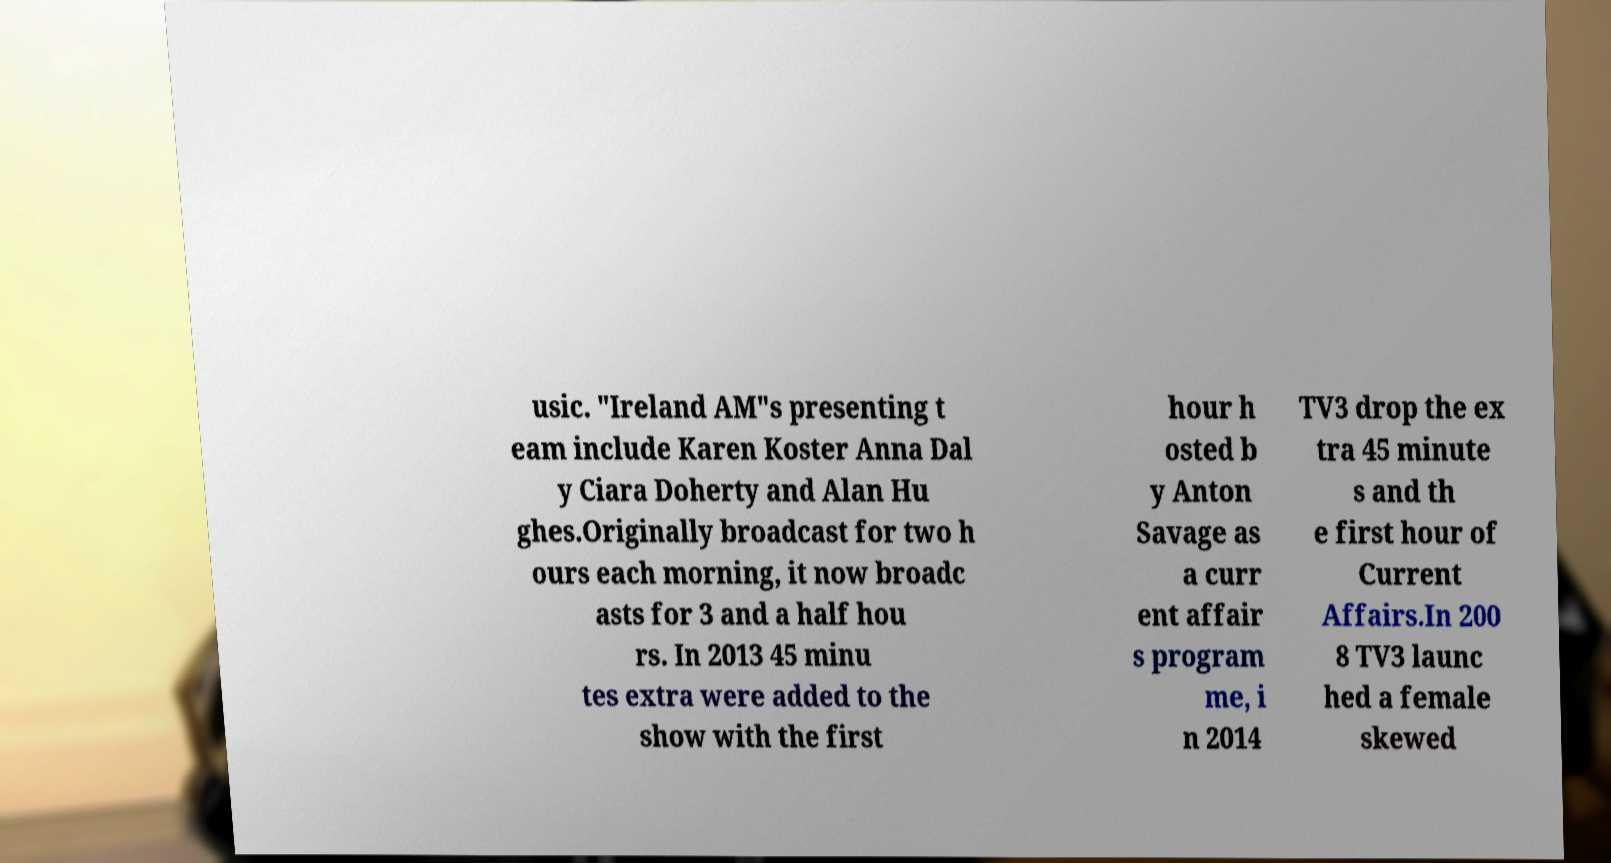Please identify and transcribe the text found in this image. usic. "Ireland AM"s presenting t eam include Karen Koster Anna Dal y Ciara Doherty and Alan Hu ghes.Originally broadcast for two h ours each morning, it now broadc asts for 3 and a half hou rs. In 2013 45 minu tes extra were added to the show with the first hour h osted b y Anton Savage as a curr ent affair s program me, i n 2014 TV3 drop the ex tra 45 minute s and th e first hour of Current Affairs.In 200 8 TV3 launc hed a female skewed 